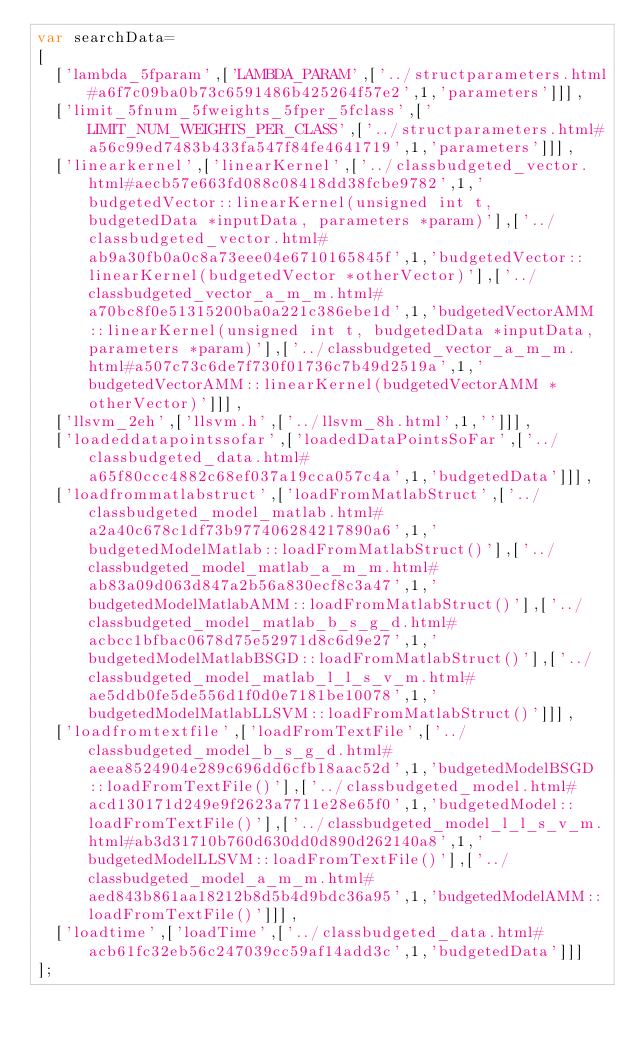Convert code to text. <code><loc_0><loc_0><loc_500><loc_500><_JavaScript_>var searchData=
[
  ['lambda_5fparam',['LAMBDA_PARAM',['../structparameters.html#a6f7c09ba0b73c6591486b425264f57e2',1,'parameters']]],
  ['limit_5fnum_5fweights_5fper_5fclass',['LIMIT_NUM_WEIGHTS_PER_CLASS',['../structparameters.html#a56c99ed7483b433fa547f84fe4641719',1,'parameters']]],
  ['linearkernel',['linearKernel',['../classbudgeted_vector.html#aecb57e663fd088c08418dd38fcbe9782',1,'budgetedVector::linearKernel(unsigned int t, budgetedData *inputData, parameters *param)'],['../classbudgeted_vector.html#ab9a30fb0a0c8a73eee04e6710165845f',1,'budgetedVector::linearKernel(budgetedVector *otherVector)'],['../classbudgeted_vector_a_m_m.html#a70bc8f0e51315200ba0a221c386ebe1d',1,'budgetedVectorAMM::linearKernel(unsigned int t, budgetedData *inputData, parameters *param)'],['../classbudgeted_vector_a_m_m.html#a507c73c6de7f730f01736c7b49d2519a',1,'budgetedVectorAMM::linearKernel(budgetedVectorAMM *otherVector)']]],
  ['llsvm_2eh',['llsvm.h',['../llsvm_8h.html',1,'']]],
  ['loadeddatapointssofar',['loadedDataPointsSoFar',['../classbudgeted_data.html#a65f80ccc4882c68ef037a19cca057c4a',1,'budgetedData']]],
  ['loadfrommatlabstruct',['loadFromMatlabStruct',['../classbudgeted_model_matlab.html#a2a40c678c1df73b977406284217890a6',1,'budgetedModelMatlab::loadFromMatlabStruct()'],['../classbudgeted_model_matlab_a_m_m.html#ab83a09d063d847a2b56a830ecf8c3a47',1,'budgetedModelMatlabAMM::loadFromMatlabStruct()'],['../classbudgeted_model_matlab_b_s_g_d.html#acbcc1bfbac0678d75e52971d8c6d9e27',1,'budgetedModelMatlabBSGD::loadFromMatlabStruct()'],['../classbudgeted_model_matlab_l_l_s_v_m.html#ae5ddb0fe5de556d1f0d0e7181be10078',1,'budgetedModelMatlabLLSVM::loadFromMatlabStruct()']]],
  ['loadfromtextfile',['loadFromTextFile',['../classbudgeted_model_b_s_g_d.html#aeea8524904e289c696dd6cfb18aac52d',1,'budgetedModelBSGD::loadFromTextFile()'],['../classbudgeted_model.html#acd130171d249e9f2623a7711e28e65f0',1,'budgetedModel::loadFromTextFile()'],['../classbudgeted_model_l_l_s_v_m.html#ab3d31710b760d630dd0d890d262140a8',1,'budgetedModelLLSVM::loadFromTextFile()'],['../classbudgeted_model_a_m_m.html#aed843b861aa18212b8d5b4d9bdc36a95',1,'budgetedModelAMM::loadFromTextFile()']]],
  ['loadtime',['loadTime',['../classbudgeted_data.html#acb61fc32eb56c247039cc59af14add3c',1,'budgetedData']]]
];
</code> 